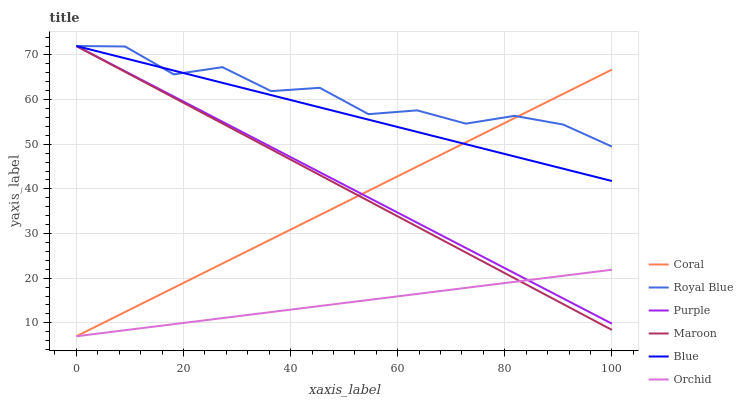Does Orchid have the minimum area under the curve?
Answer yes or no. Yes. Does Royal Blue have the maximum area under the curve?
Answer yes or no. Yes. Does Purple have the minimum area under the curve?
Answer yes or no. No. Does Purple have the maximum area under the curve?
Answer yes or no. No. Is Orchid the smoothest?
Answer yes or no. Yes. Is Royal Blue the roughest?
Answer yes or no. Yes. Is Purple the smoothest?
Answer yes or no. No. Is Purple the roughest?
Answer yes or no. No. Does Purple have the lowest value?
Answer yes or no. No. Does Royal Blue have the highest value?
Answer yes or no. Yes. Does Coral have the highest value?
Answer yes or no. No. Is Orchid less than Royal Blue?
Answer yes or no. Yes. Is Blue greater than Orchid?
Answer yes or no. Yes. Does Orchid intersect Royal Blue?
Answer yes or no. No. 